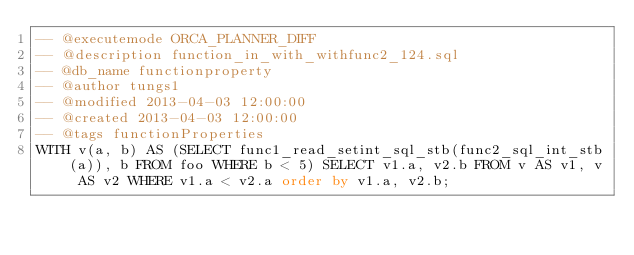<code> <loc_0><loc_0><loc_500><loc_500><_SQL_>-- @executemode ORCA_PLANNER_DIFF
-- @description function_in_with_withfunc2_124.sql
-- @db_name functionproperty
-- @author tungs1
-- @modified 2013-04-03 12:00:00
-- @created 2013-04-03 12:00:00
-- @tags functionProperties 
WITH v(a, b) AS (SELECT func1_read_setint_sql_stb(func2_sql_int_stb(a)), b FROM foo WHERE b < 5) SELECT v1.a, v2.b FROM v AS v1, v AS v2 WHERE v1.a < v2.a order by v1.a, v2.b;  
</code> 